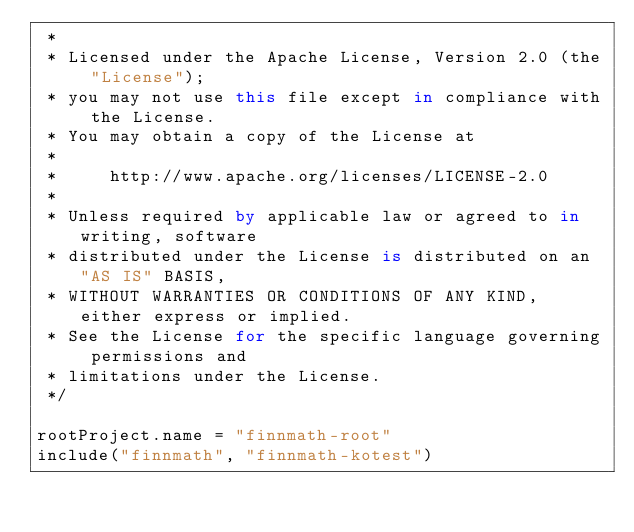Convert code to text. <code><loc_0><loc_0><loc_500><loc_500><_Kotlin_> *
 * Licensed under the Apache License, Version 2.0 (the "License");
 * you may not use this file except in compliance with the License.
 * You may obtain a copy of the License at
 *
 *     http://www.apache.org/licenses/LICENSE-2.0
 *
 * Unless required by applicable law or agreed to in writing, software
 * distributed under the License is distributed on an "AS IS" BASIS,
 * WITHOUT WARRANTIES OR CONDITIONS OF ANY KIND, either express or implied.
 * See the License for the specific language governing permissions and
 * limitations under the License.
 */

rootProject.name = "finnmath-root"
include("finnmath", "finnmath-kotest")
</code> 